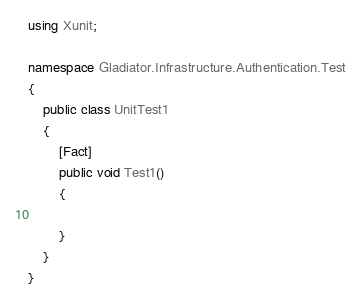Convert code to text. <code><loc_0><loc_0><loc_500><loc_500><_C#_>using Xunit;

namespace Gladiator.Infrastructure.Authentication.Test
{
    public class UnitTest1
    {
        [Fact]
        public void Test1()
        {

        }
    }
}</code> 